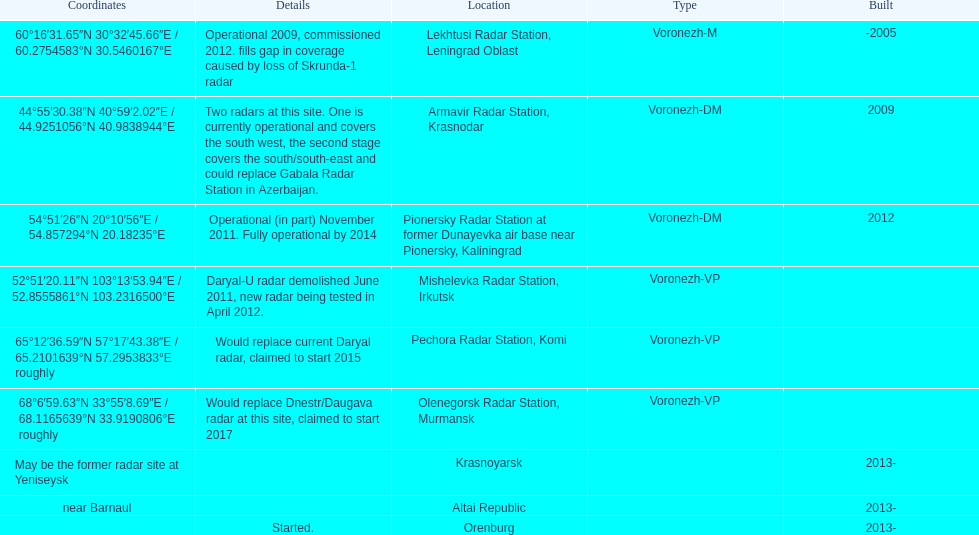What year built is at the top? -2005. 